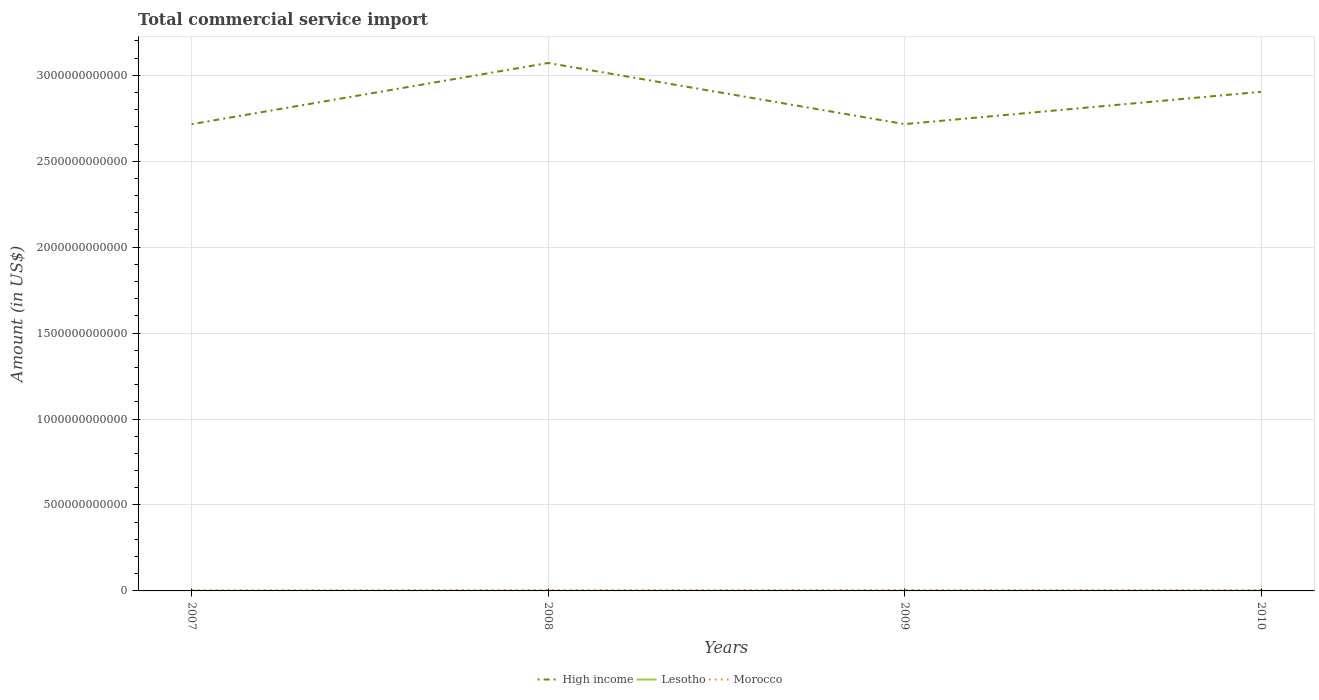Does the line corresponding to Morocco intersect with the line corresponding to High income?
Your answer should be very brief. No. Across all years, what is the maximum total commercial service import in Lesotho?
Ensure brevity in your answer.  3.54e+08. In which year was the total commercial service import in Morocco maximum?
Offer a terse response. 2007. What is the total total commercial service import in Morocco in the graph?
Offer a terse response. 3.11e+08. What is the difference between the highest and the second highest total commercial service import in Lesotho?
Your response must be concise. 5.58e+07. How many lines are there?
Keep it short and to the point. 3. How many years are there in the graph?
Make the answer very short. 4. What is the difference between two consecutive major ticks on the Y-axis?
Offer a terse response. 5.00e+11. Are the values on the major ticks of Y-axis written in scientific E-notation?
Offer a terse response. No. How many legend labels are there?
Make the answer very short. 3. What is the title of the graph?
Give a very brief answer. Total commercial service import. What is the label or title of the X-axis?
Provide a succinct answer. Years. What is the Amount (in US$) in High income in 2007?
Your response must be concise. 2.72e+12. What is the Amount (in US$) in Lesotho in 2007?
Offer a very short reply. 3.54e+08. What is the Amount (in US$) of Morocco in 2007?
Give a very brief answer. 4.53e+09. What is the Amount (in US$) of High income in 2008?
Ensure brevity in your answer.  3.07e+12. What is the Amount (in US$) in Lesotho in 2008?
Make the answer very short. 3.79e+08. What is the Amount (in US$) in Morocco in 2008?
Your answer should be very brief. 5.61e+09. What is the Amount (in US$) of High income in 2009?
Your answer should be very brief. 2.72e+12. What is the Amount (in US$) of Lesotho in 2009?
Give a very brief answer. 3.97e+08. What is the Amount (in US$) in Morocco in 2009?
Provide a succinct answer. 5.30e+09. What is the Amount (in US$) of High income in 2010?
Offer a terse response. 2.90e+12. What is the Amount (in US$) in Lesotho in 2010?
Your response must be concise. 4.10e+08. What is the Amount (in US$) in Morocco in 2010?
Provide a short and direct response. 5.66e+09. Across all years, what is the maximum Amount (in US$) in High income?
Your answer should be very brief. 3.07e+12. Across all years, what is the maximum Amount (in US$) in Lesotho?
Give a very brief answer. 4.10e+08. Across all years, what is the maximum Amount (in US$) in Morocco?
Ensure brevity in your answer.  5.66e+09. Across all years, what is the minimum Amount (in US$) in High income?
Keep it short and to the point. 2.72e+12. Across all years, what is the minimum Amount (in US$) in Lesotho?
Offer a very short reply. 3.54e+08. Across all years, what is the minimum Amount (in US$) of Morocco?
Provide a short and direct response. 4.53e+09. What is the total Amount (in US$) of High income in the graph?
Provide a succinct answer. 1.14e+13. What is the total Amount (in US$) in Lesotho in the graph?
Your answer should be very brief. 1.54e+09. What is the total Amount (in US$) of Morocco in the graph?
Your answer should be very brief. 2.11e+1. What is the difference between the Amount (in US$) in High income in 2007 and that in 2008?
Make the answer very short. -3.56e+11. What is the difference between the Amount (in US$) of Lesotho in 2007 and that in 2008?
Your answer should be very brief. -2.52e+07. What is the difference between the Amount (in US$) of Morocco in 2007 and that in 2008?
Your answer should be compact. -1.08e+09. What is the difference between the Amount (in US$) in High income in 2007 and that in 2009?
Ensure brevity in your answer.  -1.42e+08. What is the difference between the Amount (in US$) in Lesotho in 2007 and that in 2009?
Offer a very short reply. -4.28e+07. What is the difference between the Amount (in US$) of Morocco in 2007 and that in 2009?
Your response must be concise. -7.74e+08. What is the difference between the Amount (in US$) in High income in 2007 and that in 2010?
Offer a very short reply. -1.88e+11. What is the difference between the Amount (in US$) of Lesotho in 2007 and that in 2010?
Your answer should be very brief. -5.58e+07. What is the difference between the Amount (in US$) in Morocco in 2007 and that in 2010?
Make the answer very short. -1.13e+09. What is the difference between the Amount (in US$) of High income in 2008 and that in 2009?
Your answer should be very brief. 3.56e+11. What is the difference between the Amount (in US$) in Lesotho in 2008 and that in 2009?
Your answer should be very brief. -1.77e+07. What is the difference between the Amount (in US$) in Morocco in 2008 and that in 2009?
Your answer should be compact. 3.11e+08. What is the difference between the Amount (in US$) in High income in 2008 and that in 2010?
Keep it short and to the point. 1.68e+11. What is the difference between the Amount (in US$) in Lesotho in 2008 and that in 2010?
Your answer should be compact. -3.07e+07. What is the difference between the Amount (in US$) in Morocco in 2008 and that in 2010?
Make the answer very short. -4.78e+07. What is the difference between the Amount (in US$) of High income in 2009 and that in 2010?
Provide a short and direct response. -1.88e+11. What is the difference between the Amount (in US$) of Lesotho in 2009 and that in 2010?
Make the answer very short. -1.30e+07. What is the difference between the Amount (in US$) in Morocco in 2009 and that in 2010?
Ensure brevity in your answer.  -3.58e+08. What is the difference between the Amount (in US$) of High income in 2007 and the Amount (in US$) of Lesotho in 2008?
Keep it short and to the point. 2.72e+12. What is the difference between the Amount (in US$) of High income in 2007 and the Amount (in US$) of Morocco in 2008?
Your response must be concise. 2.71e+12. What is the difference between the Amount (in US$) of Lesotho in 2007 and the Amount (in US$) of Morocco in 2008?
Provide a succinct answer. -5.26e+09. What is the difference between the Amount (in US$) of High income in 2007 and the Amount (in US$) of Lesotho in 2009?
Your answer should be compact. 2.72e+12. What is the difference between the Amount (in US$) in High income in 2007 and the Amount (in US$) in Morocco in 2009?
Provide a short and direct response. 2.71e+12. What is the difference between the Amount (in US$) in Lesotho in 2007 and the Amount (in US$) in Morocco in 2009?
Offer a very short reply. -4.95e+09. What is the difference between the Amount (in US$) in High income in 2007 and the Amount (in US$) in Lesotho in 2010?
Give a very brief answer. 2.72e+12. What is the difference between the Amount (in US$) of High income in 2007 and the Amount (in US$) of Morocco in 2010?
Give a very brief answer. 2.71e+12. What is the difference between the Amount (in US$) in Lesotho in 2007 and the Amount (in US$) in Morocco in 2010?
Offer a terse response. -5.31e+09. What is the difference between the Amount (in US$) of High income in 2008 and the Amount (in US$) of Lesotho in 2009?
Give a very brief answer. 3.07e+12. What is the difference between the Amount (in US$) of High income in 2008 and the Amount (in US$) of Morocco in 2009?
Offer a very short reply. 3.07e+12. What is the difference between the Amount (in US$) in Lesotho in 2008 and the Amount (in US$) in Morocco in 2009?
Give a very brief answer. -4.92e+09. What is the difference between the Amount (in US$) in High income in 2008 and the Amount (in US$) in Lesotho in 2010?
Your response must be concise. 3.07e+12. What is the difference between the Amount (in US$) of High income in 2008 and the Amount (in US$) of Morocco in 2010?
Your answer should be compact. 3.07e+12. What is the difference between the Amount (in US$) of Lesotho in 2008 and the Amount (in US$) of Morocco in 2010?
Provide a short and direct response. -5.28e+09. What is the difference between the Amount (in US$) of High income in 2009 and the Amount (in US$) of Lesotho in 2010?
Give a very brief answer. 2.72e+12. What is the difference between the Amount (in US$) in High income in 2009 and the Amount (in US$) in Morocco in 2010?
Keep it short and to the point. 2.71e+12. What is the difference between the Amount (in US$) in Lesotho in 2009 and the Amount (in US$) in Morocco in 2010?
Provide a succinct answer. -5.26e+09. What is the average Amount (in US$) in High income per year?
Your response must be concise. 2.85e+12. What is the average Amount (in US$) of Lesotho per year?
Offer a terse response. 3.85e+08. What is the average Amount (in US$) in Morocco per year?
Give a very brief answer. 5.27e+09. In the year 2007, what is the difference between the Amount (in US$) in High income and Amount (in US$) in Lesotho?
Your answer should be very brief. 2.72e+12. In the year 2007, what is the difference between the Amount (in US$) of High income and Amount (in US$) of Morocco?
Keep it short and to the point. 2.71e+12. In the year 2007, what is the difference between the Amount (in US$) of Lesotho and Amount (in US$) of Morocco?
Ensure brevity in your answer.  -4.17e+09. In the year 2008, what is the difference between the Amount (in US$) in High income and Amount (in US$) in Lesotho?
Keep it short and to the point. 3.07e+12. In the year 2008, what is the difference between the Amount (in US$) in High income and Amount (in US$) in Morocco?
Offer a terse response. 3.07e+12. In the year 2008, what is the difference between the Amount (in US$) of Lesotho and Amount (in US$) of Morocco?
Your response must be concise. -5.23e+09. In the year 2009, what is the difference between the Amount (in US$) in High income and Amount (in US$) in Lesotho?
Ensure brevity in your answer.  2.72e+12. In the year 2009, what is the difference between the Amount (in US$) in High income and Amount (in US$) in Morocco?
Give a very brief answer. 2.71e+12. In the year 2009, what is the difference between the Amount (in US$) of Lesotho and Amount (in US$) of Morocco?
Your answer should be very brief. -4.90e+09. In the year 2010, what is the difference between the Amount (in US$) of High income and Amount (in US$) of Lesotho?
Provide a short and direct response. 2.90e+12. In the year 2010, what is the difference between the Amount (in US$) in High income and Amount (in US$) in Morocco?
Offer a terse response. 2.90e+12. In the year 2010, what is the difference between the Amount (in US$) in Lesotho and Amount (in US$) in Morocco?
Provide a succinct answer. -5.25e+09. What is the ratio of the Amount (in US$) of High income in 2007 to that in 2008?
Make the answer very short. 0.88. What is the ratio of the Amount (in US$) in Lesotho in 2007 to that in 2008?
Give a very brief answer. 0.93. What is the ratio of the Amount (in US$) of Morocco in 2007 to that in 2008?
Your response must be concise. 0.81. What is the ratio of the Amount (in US$) of High income in 2007 to that in 2009?
Provide a succinct answer. 1. What is the ratio of the Amount (in US$) in Lesotho in 2007 to that in 2009?
Your answer should be very brief. 0.89. What is the ratio of the Amount (in US$) of Morocco in 2007 to that in 2009?
Your answer should be compact. 0.85. What is the ratio of the Amount (in US$) in High income in 2007 to that in 2010?
Keep it short and to the point. 0.94. What is the ratio of the Amount (in US$) of Lesotho in 2007 to that in 2010?
Make the answer very short. 0.86. What is the ratio of the Amount (in US$) of High income in 2008 to that in 2009?
Offer a terse response. 1.13. What is the ratio of the Amount (in US$) of Lesotho in 2008 to that in 2009?
Keep it short and to the point. 0.96. What is the ratio of the Amount (in US$) in Morocco in 2008 to that in 2009?
Your answer should be compact. 1.06. What is the ratio of the Amount (in US$) of High income in 2008 to that in 2010?
Your answer should be compact. 1.06. What is the ratio of the Amount (in US$) of Lesotho in 2008 to that in 2010?
Offer a terse response. 0.93. What is the ratio of the Amount (in US$) of High income in 2009 to that in 2010?
Ensure brevity in your answer.  0.94. What is the ratio of the Amount (in US$) of Lesotho in 2009 to that in 2010?
Keep it short and to the point. 0.97. What is the ratio of the Amount (in US$) of Morocco in 2009 to that in 2010?
Your response must be concise. 0.94. What is the difference between the highest and the second highest Amount (in US$) of High income?
Your answer should be very brief. 1.68e+11. What is the difference between the highest and the second highest Amount (in US$) in Lesotho?
Give a very brief answer. 1.30e+07. What is the difference between the highest and the second highest Amount (in US$) of Morocco?
Your answer should be compact. 4.78e+07. What is the difference between the highest and the lowest Amount (in US$) of High income?
Ensure brevity in your answer.  3.56e+11. What is the difference between the highest and the lowest Amount (in US$) of Lesotho?
Provide a short and direct response. 5.58e+07. What is the difference between the highest and the lowest Amount (in US$) in Morocco?
Your answer should be compact. 1.13e+09. 